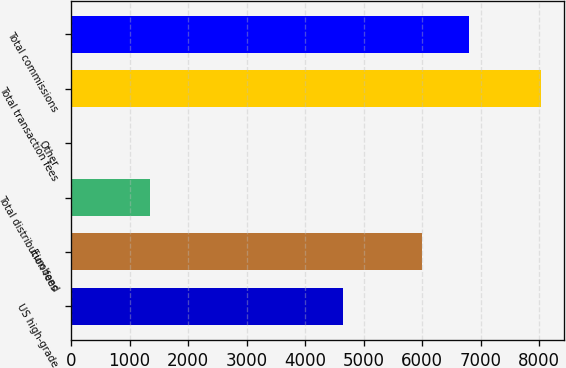<chart> <loc_0><loc_0><loc_500><loc_500><bar_chart><fcel>US high-grade<fcel>Eurobond<fcel>Total distribution fees<fcel>Other<fcel>Total transaction fees<fcel>Total commissions<nl><fcel>4652<fcel>5995<fcel>1343<fcel>10<fcel>8029<fcel>6796.9<nl></chart> 